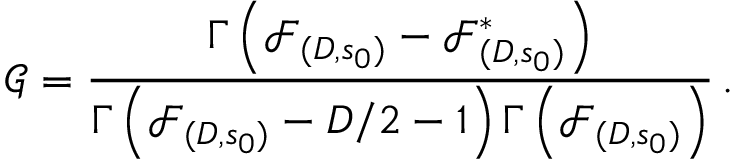<formula> <loc_0><loc_0><loc_500><loc_500>\mathcal { G } = \frac { \Gamma \left ( \mathcal { F } _ { ( D , s _ { 0 } ) } - \mathcal { F } _ { ( D , s _ { 0 } ) } ^ { * } \right ) } { \Gamma \left ( \mathcal { F } _ { ( D , s _ { 0 } ) } - D / 2 - 1 \right ) \Gamma \left ( \mathcal { F } _ { ( D , s _ { 0 } ) } \right ) } \, .</formula> 